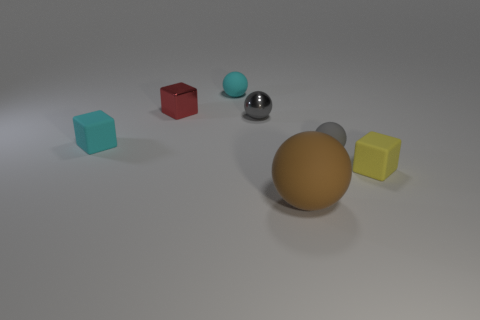Add 3 large brown spheres. How many objects exist? 10 Subtract all spheres. How many objects are left? 3 Add 2 small red shiny things. How many small red shiny things exist? 3 Subtract 0 blue spheres. How many objects are left? 7 Subtract all cyan spheres. Subtract all gray shiny balls. How many objects are left? 5 Add 5 red things. How many red things are left? 6 